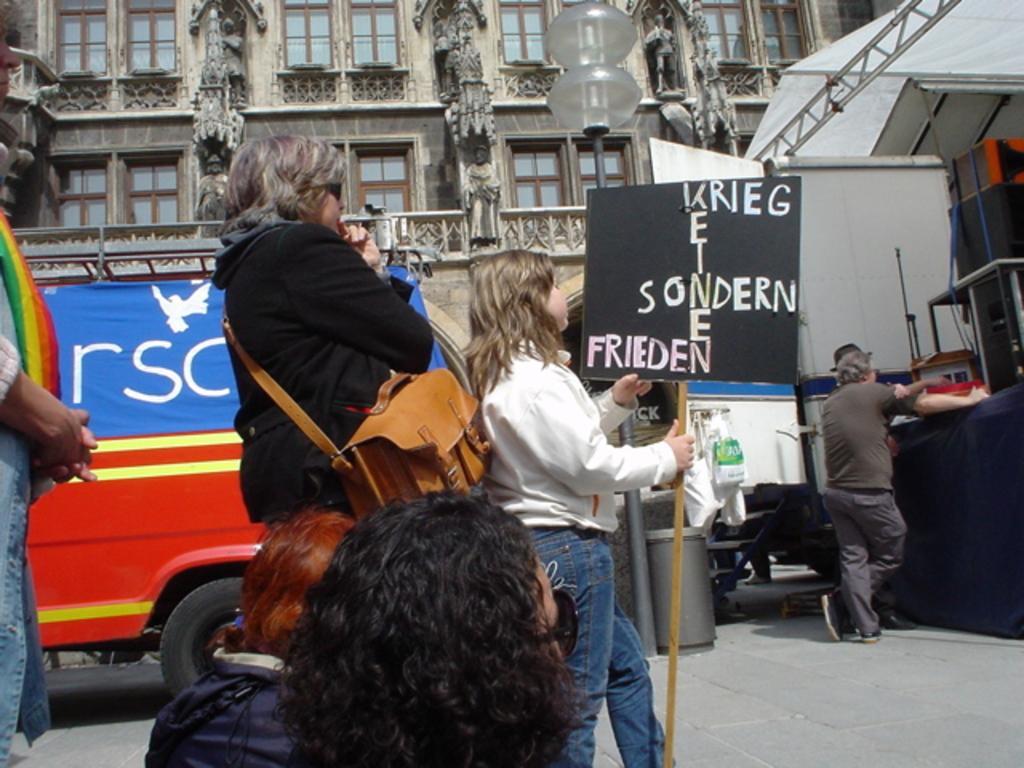Please provide a concise description of this image. In this image there is a girl walking, holding a placard in her hand, behind the girl there is a woman, beside the women there are two other persons sitting on the floor, beside the woman there is a van on the road surface, in front of the girl there are two other persons standing, in the background of the image there is a building. 